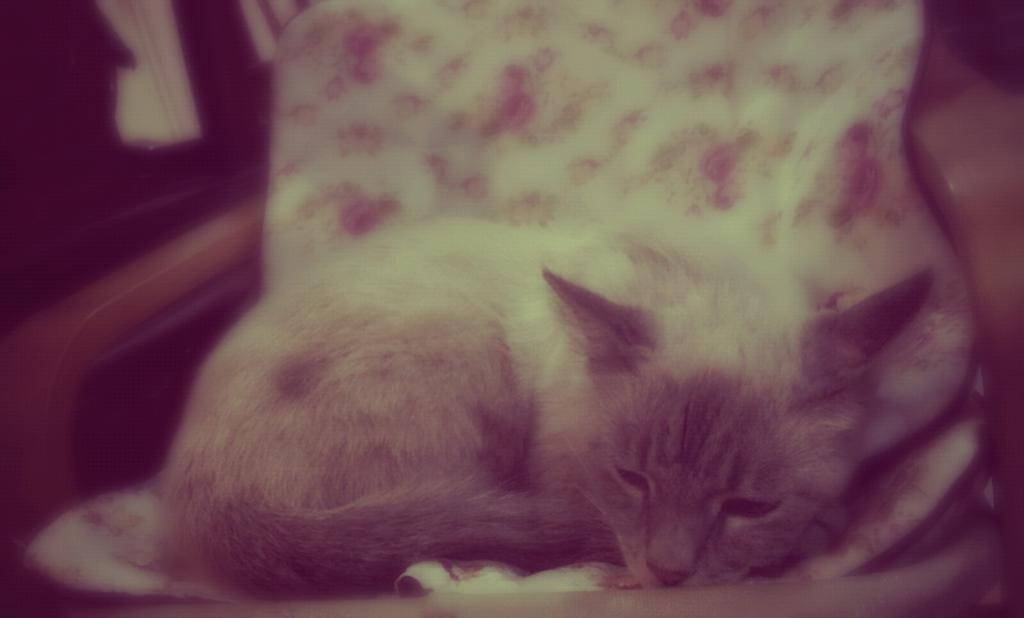What animal is present in the image? There is a cat in the picture. What is the cat doing in the image? The cat is sitting on a chair. Can you describe the background of the image? The background of the image is blurred. What type of yam is the cat holding in the image? There is no yam present in the image; it features a cat sitting on a chair. What role does the rake play in the image? There is no rake present in the image. 